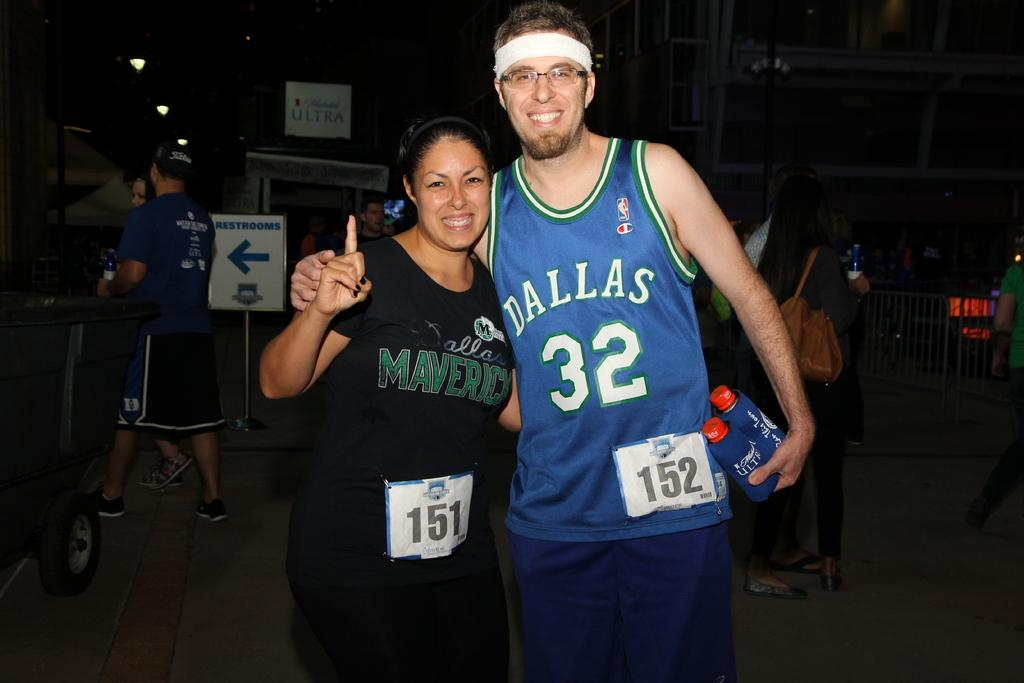<image>
Create a compact narrative representing the image presented. A Dallas fan is pictured with a friend holding two drinks 